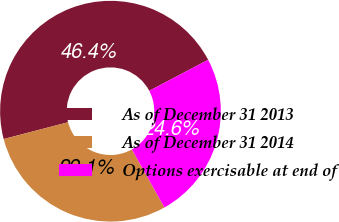Convert chart. <chart><loc_0><loc_0><loc_500><loc_500><pie_chart><fcel>As of December 31 2013<fcel>As of December 31 2014<fcel>Options exercisable at end of<nl><fcel>46.36%<fcel>29.07%<fcel>24.58%<nl></chart> 